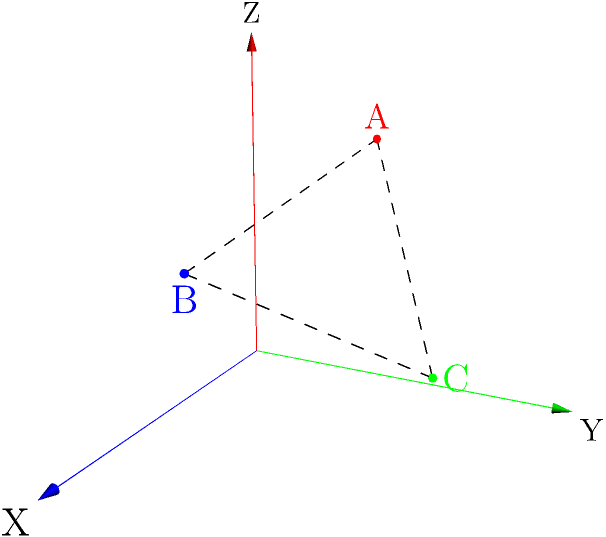In your latest mystery thriller, you're mapping out a complex crime scene across multiple levels of a building. Using a 3D coordinate system, you've plotted three key pieces of evidence: A(1,2,3), B(3,1,2), and C(2,3,1). What is the volume of the tetrahedron formed by these points and the origin (0,0,0)? (Round your answer to two decimal places) To find the volume of the tetrahedron, we can use the following steps:

1. The volume of a tetrahedron can be calculated using the formula:
   $$ V = \frac{1}{6}|det(a-d, b-d, c-d)| $$
   where a, b, c are the coordinates of three vertices, and d is the fourth vertex.

2. In our case, d is the origin (0,0,0), so we can simplify to:
   $$ V = \frac{1}{6}|det(a, b, c)| $$

3. Let's create the matrix using our points:
   $$ \begin{vmatrix} 
   1 & 3 & 2 \\
   2 & 1 & 3 \\
   3 & 2 & 1
   \end{vmatrix} $$

4. Calculate the determinant:
   $$ (1 \cdot 1 \cdot 1) + (3 \cdot 3 \cdot 2) + (2 \cdot 2 \cdot 3) - (2 \cdot 1 \cdot 2) - (1 \cdot 3 \cdot 3) - (3 \cdot 2 \cdot 1) $$
   $$ = 1 + 18 + 12 - 4 - 9 - 6 = 12 $$

5. Apply the volume formula:
   $$ V = \frac{1}{6} \cdot 12 = 2 $$

Therefore, the volume of the tetrahedron is 2 cubic units.
Answer: 2.00 cubic units 